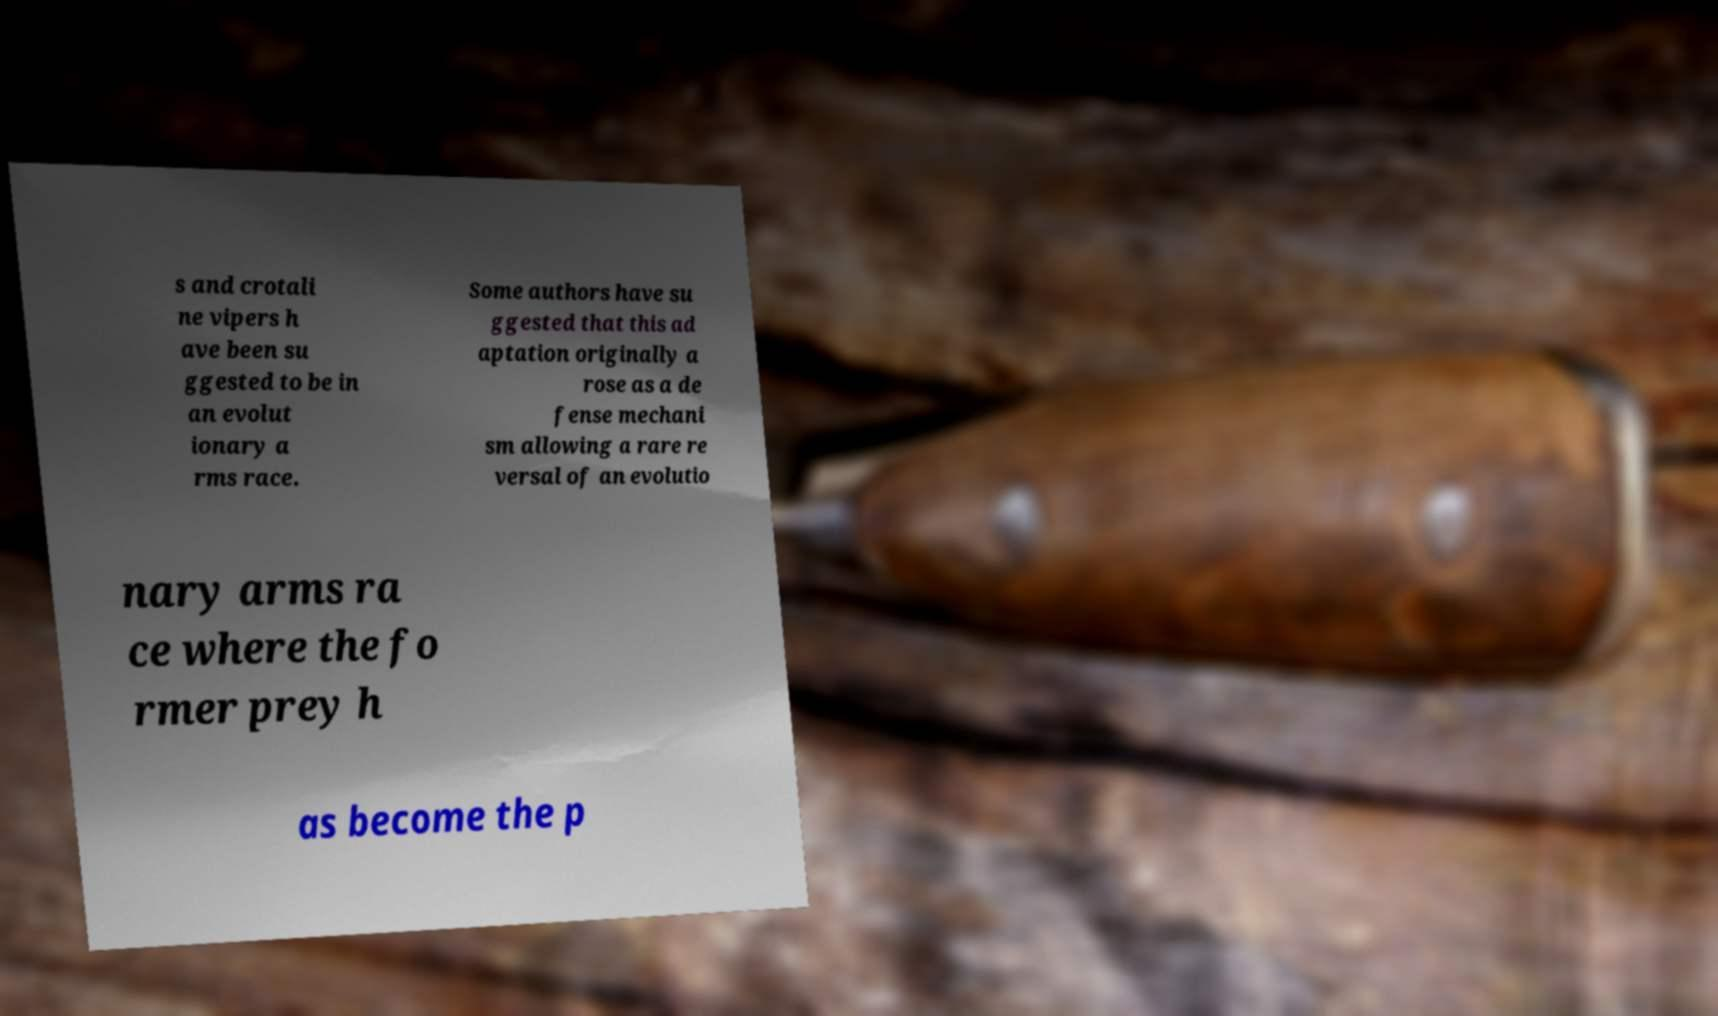I need the written content from this picture converted into text. Can you do that? s and crotali ne vipers h ave been su ggested to be in an evolut ionary a rms race. Some authors have su ggested that this ad aptation originally a rose as a de fense mechani sm allowing a rare re versal of an evolutio nary arms ra ce where the fo rmer prey h as become the p 